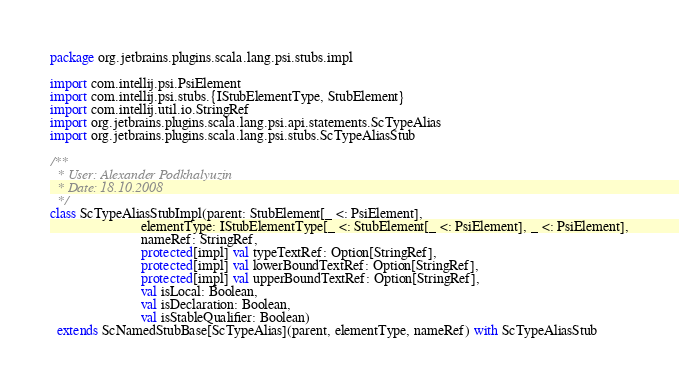Convert code to text. <code><loc_0><loc_0><loc_500><loc_500><_Scala_>package org.jetbrains.plugins.scala.lang.psi.stubs.impl

import com.intellij.psi.PsiElement
import com.intellij.psi.stubs.{IStubElementType, StubElement}
import com.intellij.util.io.StringRef
import org.jetbrains.plugins.scala.lang.psi.api.statements.ScTypeAlias
import org.jetbrains.plugins.scala.lang.psi.stubs.ScTypeAliasStub

/**
  * User: Alexander Podkhalyuzin
  * Date: 18.10.2008
  */
class ScTypeAliasStubImpl(parent: StubElement[_ <: PsiElement],
                          elementType: IStubElementType[_ <: StubElement[_ <: PsiElement], _ <: PsiElement],
                          nameRef: StringRef,
                          protected[impl] val typeTextRef: Option[StringRef],
                          protected[impl] val lowerBoundTextRef: Option[StringRef],
                          protected[impl] val upperBoundTextRef: Option[StringRef],
                          val isLocal: Boolean,
                          val isDeclaration: Boolean,
                          val isStableQualifier: Boolean)
  extends ScNamedStubBase[ScTypeAlias](parent, elementType, nameRef) with ScTypeAliasStub
</code> 